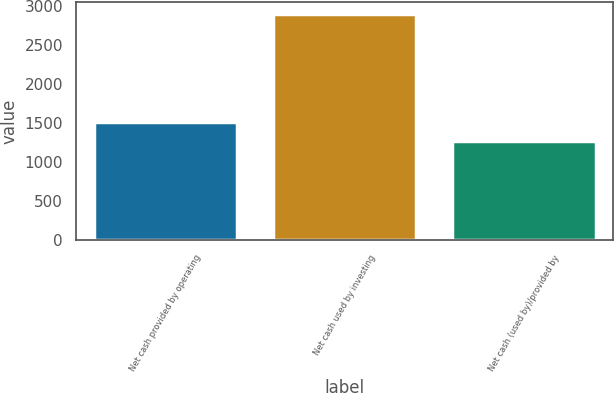<chart> <loc_0><loc_0><loc_500><loc_500><bar_chart><fcel>Net cash provided by operating<fcel>Net cash used by investing<fcel>Net cash (used by)/provided by<nl><fcel>1510<fcel>2903<fcel>1265<nl></chart> 